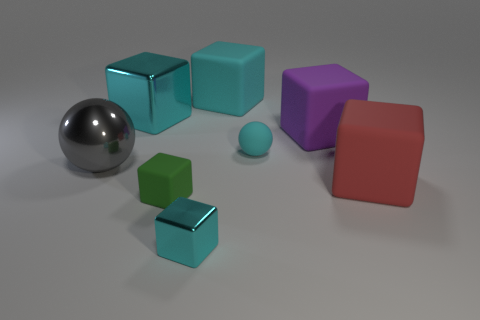The big metal sphere is what color?
Make the answer very short. Gray. Is there a green cube that has the same material as the large purple thing?
Offer a very short reply. Yes. Is there a green rubber object that is behind the large thing to the right of the big purple rubber thing that is in front of the big cyan rubber thing?
Give a very brief answer. No. There is a big metallic sphere; are there any big gray things behind it?
Keep it short and to the point. No. Is there a large object that has the same color as the big ball?
Your response must be concise. No. How many large objects are red rubber things or cyan things?
Your response must be concise. 3. Does the cyan cube that is in front of the red matte block have the same material as the cyan ball?
Offer a very short reply. No. There is a cyan metallic object on the left side of the rubber cube left of the small metal object in front of the gray metal object; what shape is it?
Make the answer very short. Cube. How many purple objects are matte objects or big metallic cylinders?
Offer a terse response. 1. Are there an equal number of tiny cyan objects on the right side of the large cyan rubber block and big gray shiny spheres that are to the right of the large red object?
Make the answer very short. No. 